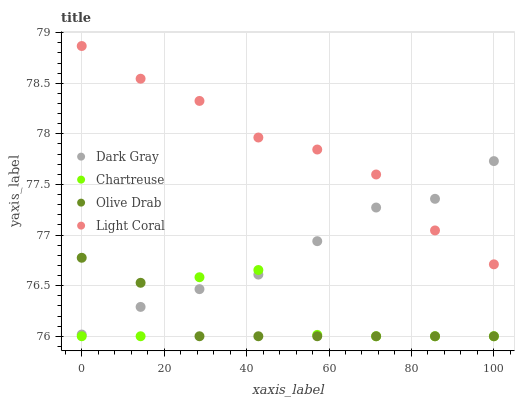Does Olive Drab have the minimum area under the curve?
Answer yes or no. Yes. Does Light Coral have the maximum area under the curve?
Answer yes or no. Yes. Does Chartreuse have the minimum area under the curve?
Answer yes or no. No. Does Chartreuse have the maximum area under the curve?
Answer yes or no. No. Is Olive Drab the smoothest?
Answer yes or no. Yes. Is Chartreuse the roughest?
Answer yes or no. Yes. Is Light Coral the smoothest?
Answer yes or no. No. Is Light Coral the roughest?
Answer yes or no. No. Does Chartreuse have the lowest value?
Answer yes or no. Yes. Does Light Coral have the lowest value?
Answer yes or no. No. Does Light Coral have the highest value?
Answer yes or no. Yes. Does Chartreuse have the highest value?
Answer yes or no. No. Is Olive Drab less than Light Coral?
Answer yes or no. Yes. Is Light Coral greater than Chartreuse?
Answer yes or no. Yes. Does Olive Drab intersect Chartreuse?
Answer yes or no. Yes. Is Olive Drab less than Chartreuse?
Answer yes or no. No. Is Olive Drab greater than Chartreuse?
Answer yes or no. No. Does Olive Drab intersect Light Coral?
Answer yes or no. No. 